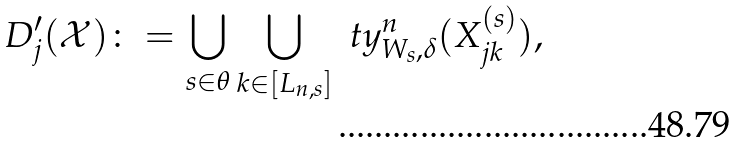Convert formula to latex. <formula><loc_0><loc_0><loc_500><loc_500>D ^ { \prime } _ { j } ( \mathcal { X } ) \colon = \bigcup _ { s \in \theta } \bigcup _ { k \in [ L _ { n , s } ] } \ t y _ { W _ { s } , \delta } ^ { n } ( X _ { j k } ^ { ( s ) } ) ,</formula> 